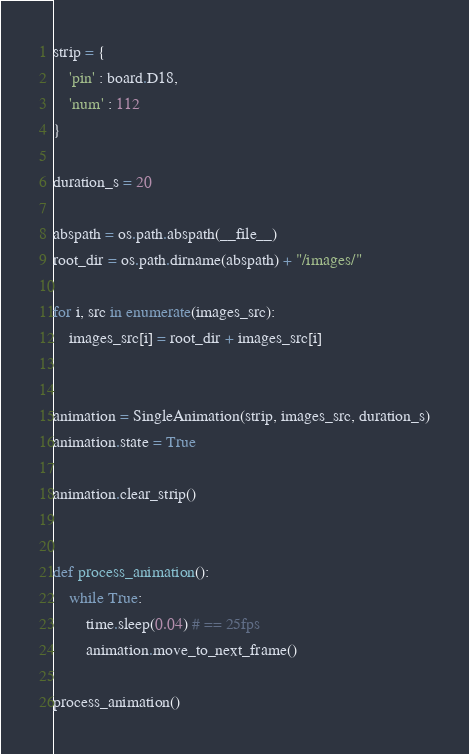<code> <loc_0><loc_0><loc_500><loc_500><_Python_>strip = {
    'pin' : board.D18,
    'num' : 112
}

duration_s = 20

abspath = os.path.abspath(__file__)
root_dir = os.path.dirname(abspath) + "/images/"

for i, src in enumerate(images_src): 
    images_src[i] = root_dir + images_src[i]


animation = SingleAnimation(strip, images_src, duration_s)
animation.state = True

animation.clear_strip()


def process_animation():
    while True:
        time.sleep(0.04) # == 25fps
        animation.move_to_next_frame()

process_animation()</code> 